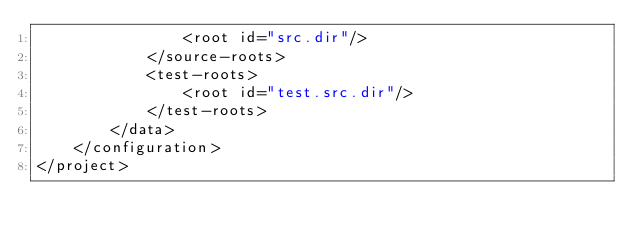<code> <loc_0><loc_0><loc_500><loc_500><_XML_>                <root id="src.dir"/>
            </source-roots>
            <test-roots>
                <root id="test.src.dir"/>
            </test-roots>
        </data>
    </configuration>
</project>
</code> 